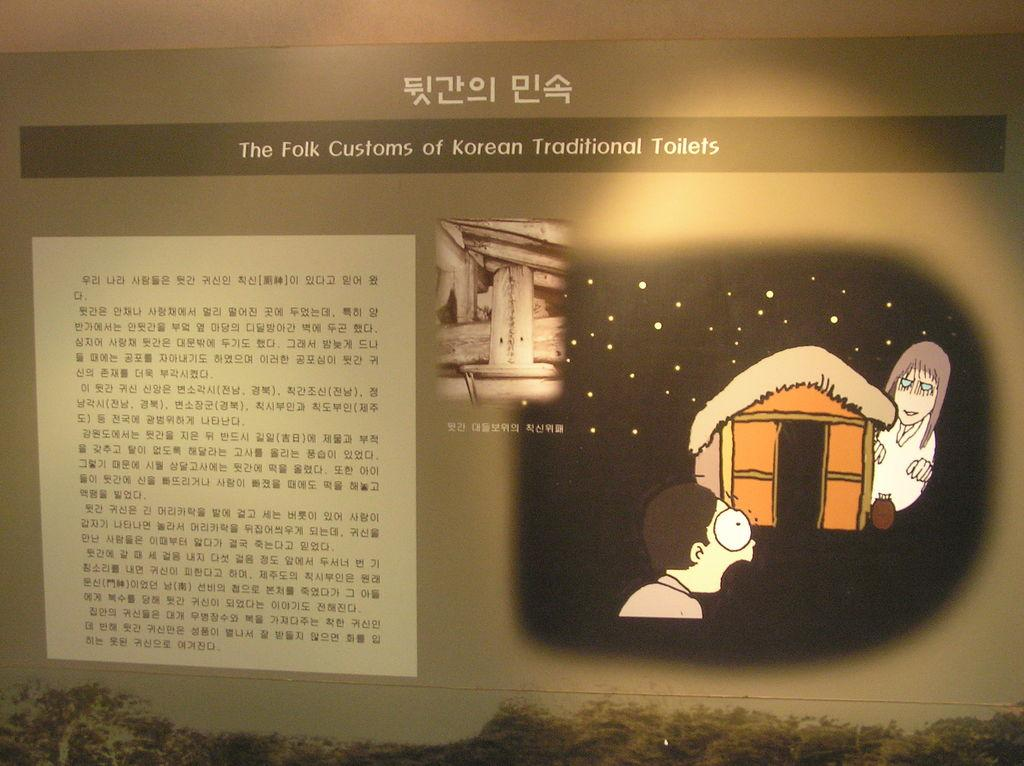<image>
Offer a succinct explanation of the picture presented. An information panel is lit up showing a scared man seeing a ghost with the words "The Folk Customs of Korean Traditional Toilets" 